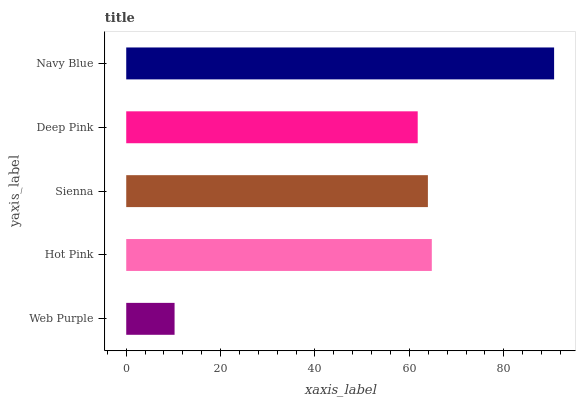Is Web Purple the minimum?
Answer yes or no. Yes. Is Navy Blue the maximum?
Answer yes or no. Yes. Is Hot Pink the minimum?
Answer yes or no. No. Is Hot Pink the maximum?
Answer yes or no. No. Is Hot Pink greater than Web Purple?
Answer yes or no. Yes. Is Web Purple less than Hot Pink?
Answer yes or no. Yes. Is Web Purple greater than Hot Pink?
Answer yes or no. No. Is Hot Pink less than Web Purple?
Answer yes or no. No. Is Sienna the high median?
Answer yes or no. Yes. Is Sienna the low median?
Answer yes or no. Yes. Is Deep Pink the high median?
Answer yes or no. No. Is Hot Pink the low median?
Answer yes or no. No. 